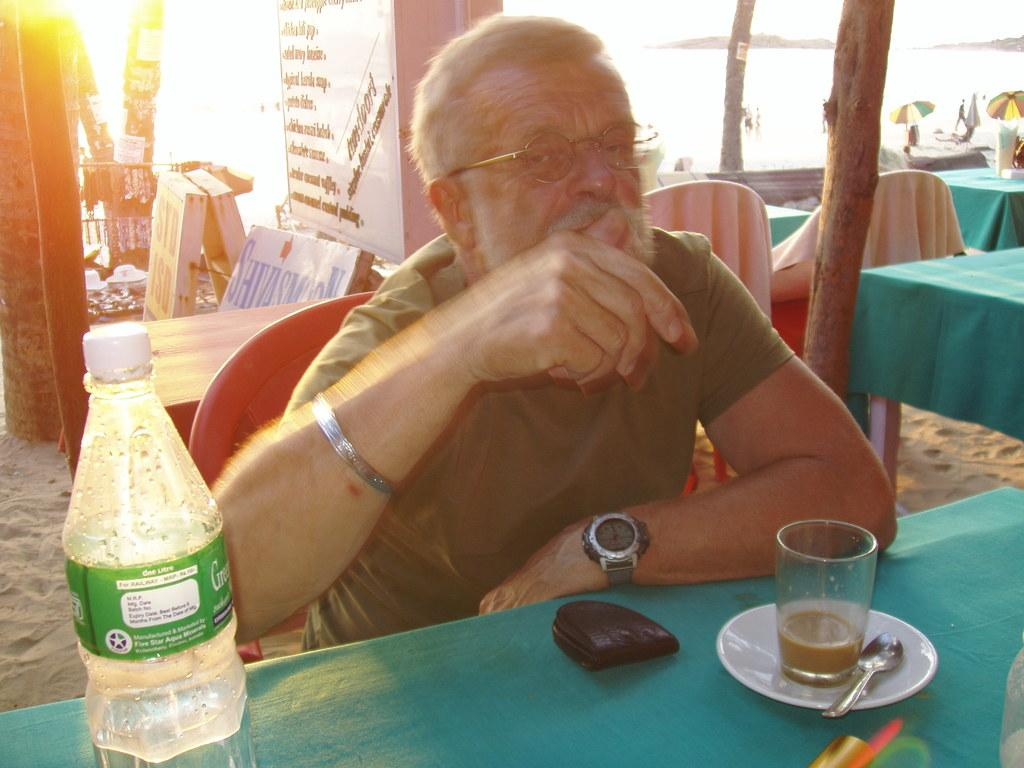Who is present in the image? There is a man in the image. What is the man doing in the image? The man is sitting on a chair. What is in front of the man? There is a table in front of the man. What can be seen in the background of the image? There are boards, chairs, and tables in the background of the image. What advice does the man give to the screw in the image? There is no screw present in the image, and therefore no advice can be given. 